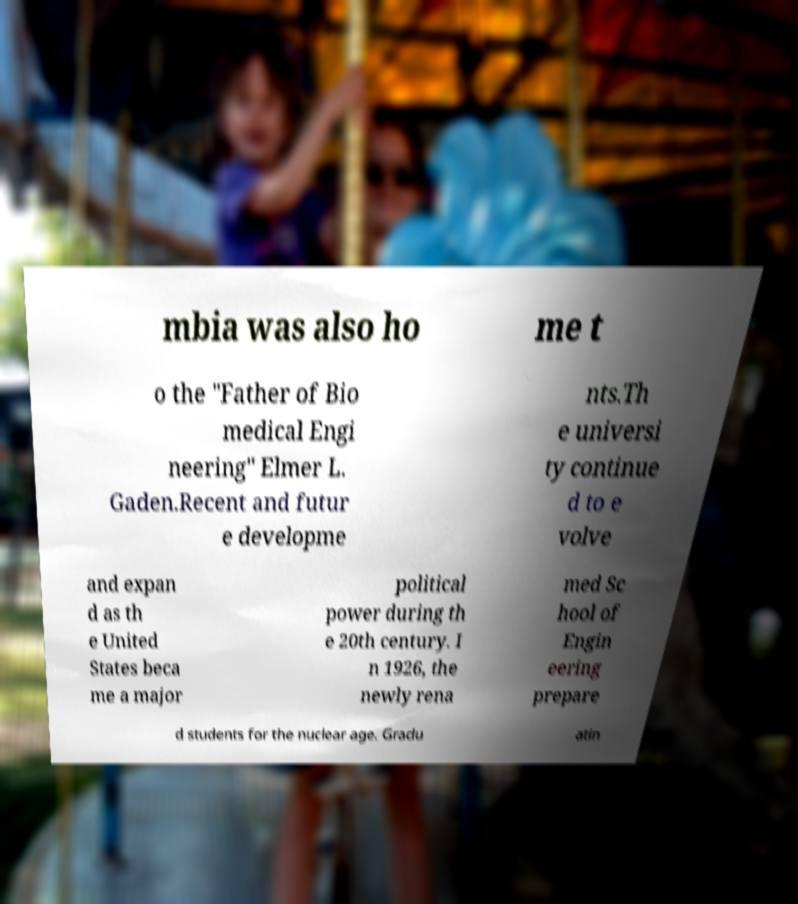Could you assist in decoding the text presented in this image and type it out clearly? mbia was also ho me t o the "Father of Bio medical Engi neering" Elmer L. Gaden.Recent and futur e developme nts.Th e universi ty continue d to e volve and expan d as th e United States beca me a major political power during th e 20th century. I n 1926, the newly rena med Sc hool of Engin eering prepare d students for the nuclear age. Gradu atin 